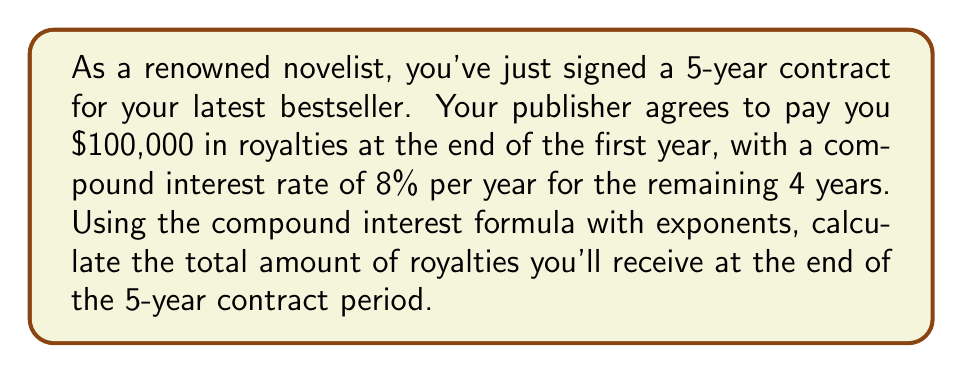Can you answer this question? To solve this problem, we'll use the compound interest formula:

$$A = P(1 + r)^n$$

Where:
$A$ = final amount
$P$ = principal (initial investment)
$r$ = annual interest rate (in decimal form)
$n$ = number of years

Given:
$P = \$100,000$ (initial royalty payment)
$r = 0.08$ (8% converted to decimal)
$n = 4$ (compound interest applies for 4 years after the first year)

Let's plug these values into the formula:

$$A = 100,000(1 + 0.08)^4$$

Now, let's solve step-by-step:

1) First, calculate $(1 + 0.08)^4$:
   $$(1.08)^4 = 1.36048896$$

2) Multiply this result by the principal:
   $$100,000 \times 1.36048896 = 136,048.896$$

Therefore, the total amount of royalties at the end of the 5-year contract will be $136,048.90 (rounded to the nearest cent).
Answer: $136,048.90 